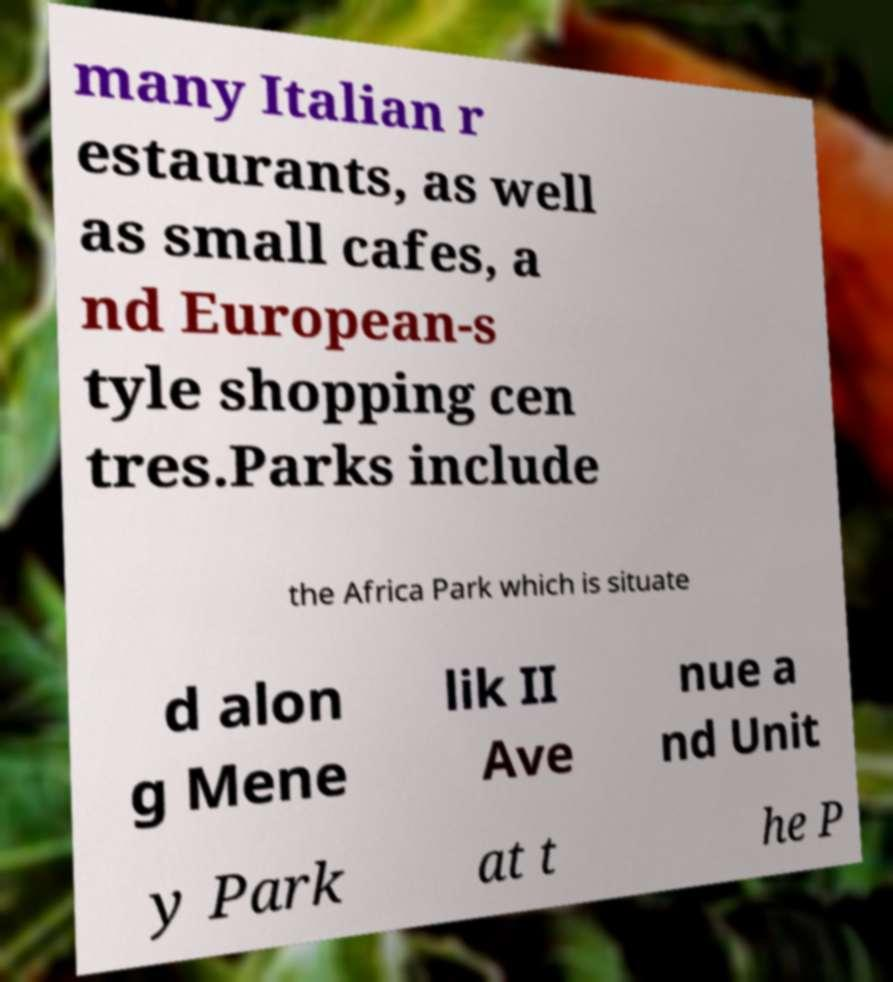Please identify and transcribe the text found in this image. many Italian r estaurants, as well as small cafes, a nd European-s tyle shopping cen tres.Parks include the Africa Park which is situate d alon g Mene lik II Ave nue a nd Unit y Park at t he P 